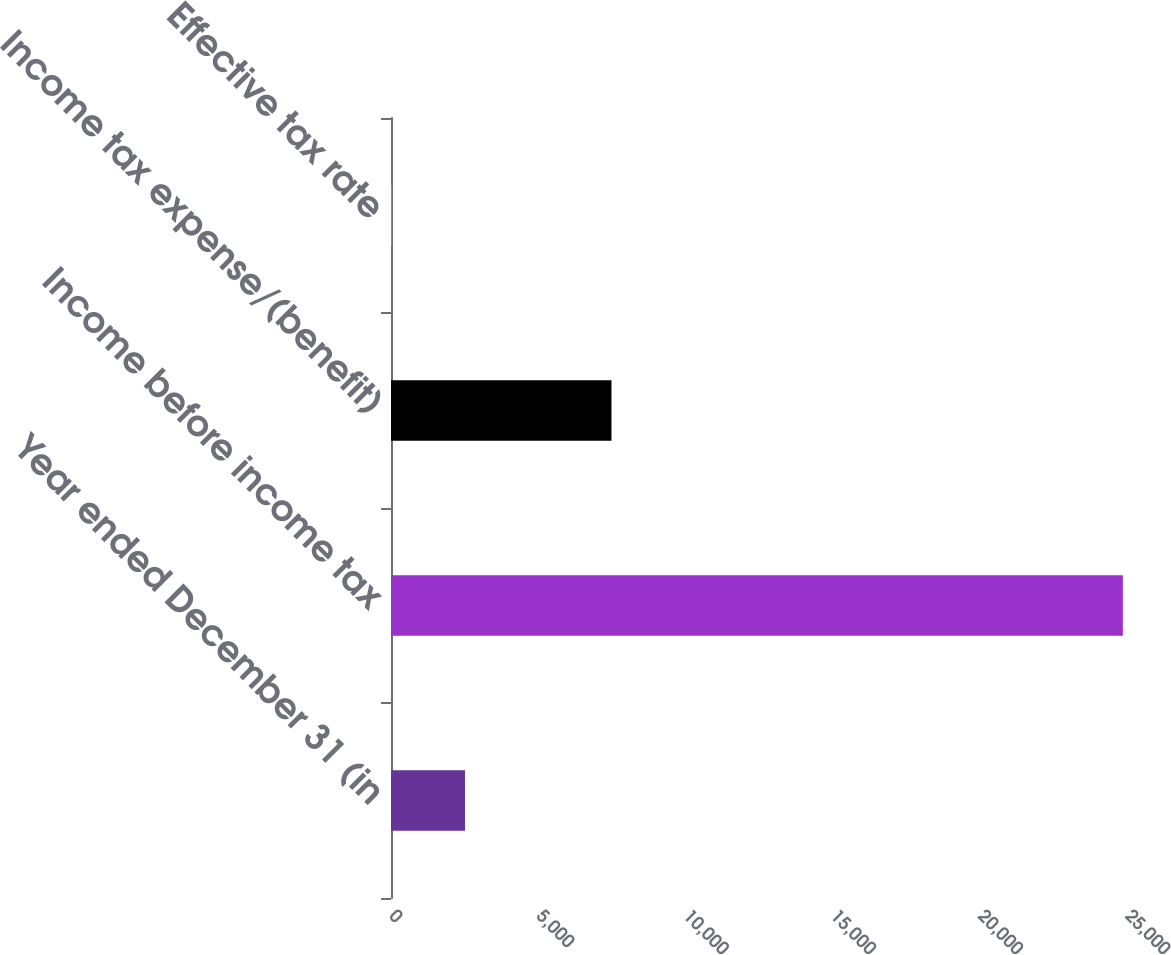Convert chart. <chart><loc_0><loc_0><loc_500><loc_500><bar_chart><fcel>Year ended December 31 (in<fcel>Income before income tax<fcel>Income tax expense/(benefit)<fcel>Effective tax rate<nl><fcel>2512.99<fcel>24859<fcel>7489<fcel>30.1<nl></chart> 